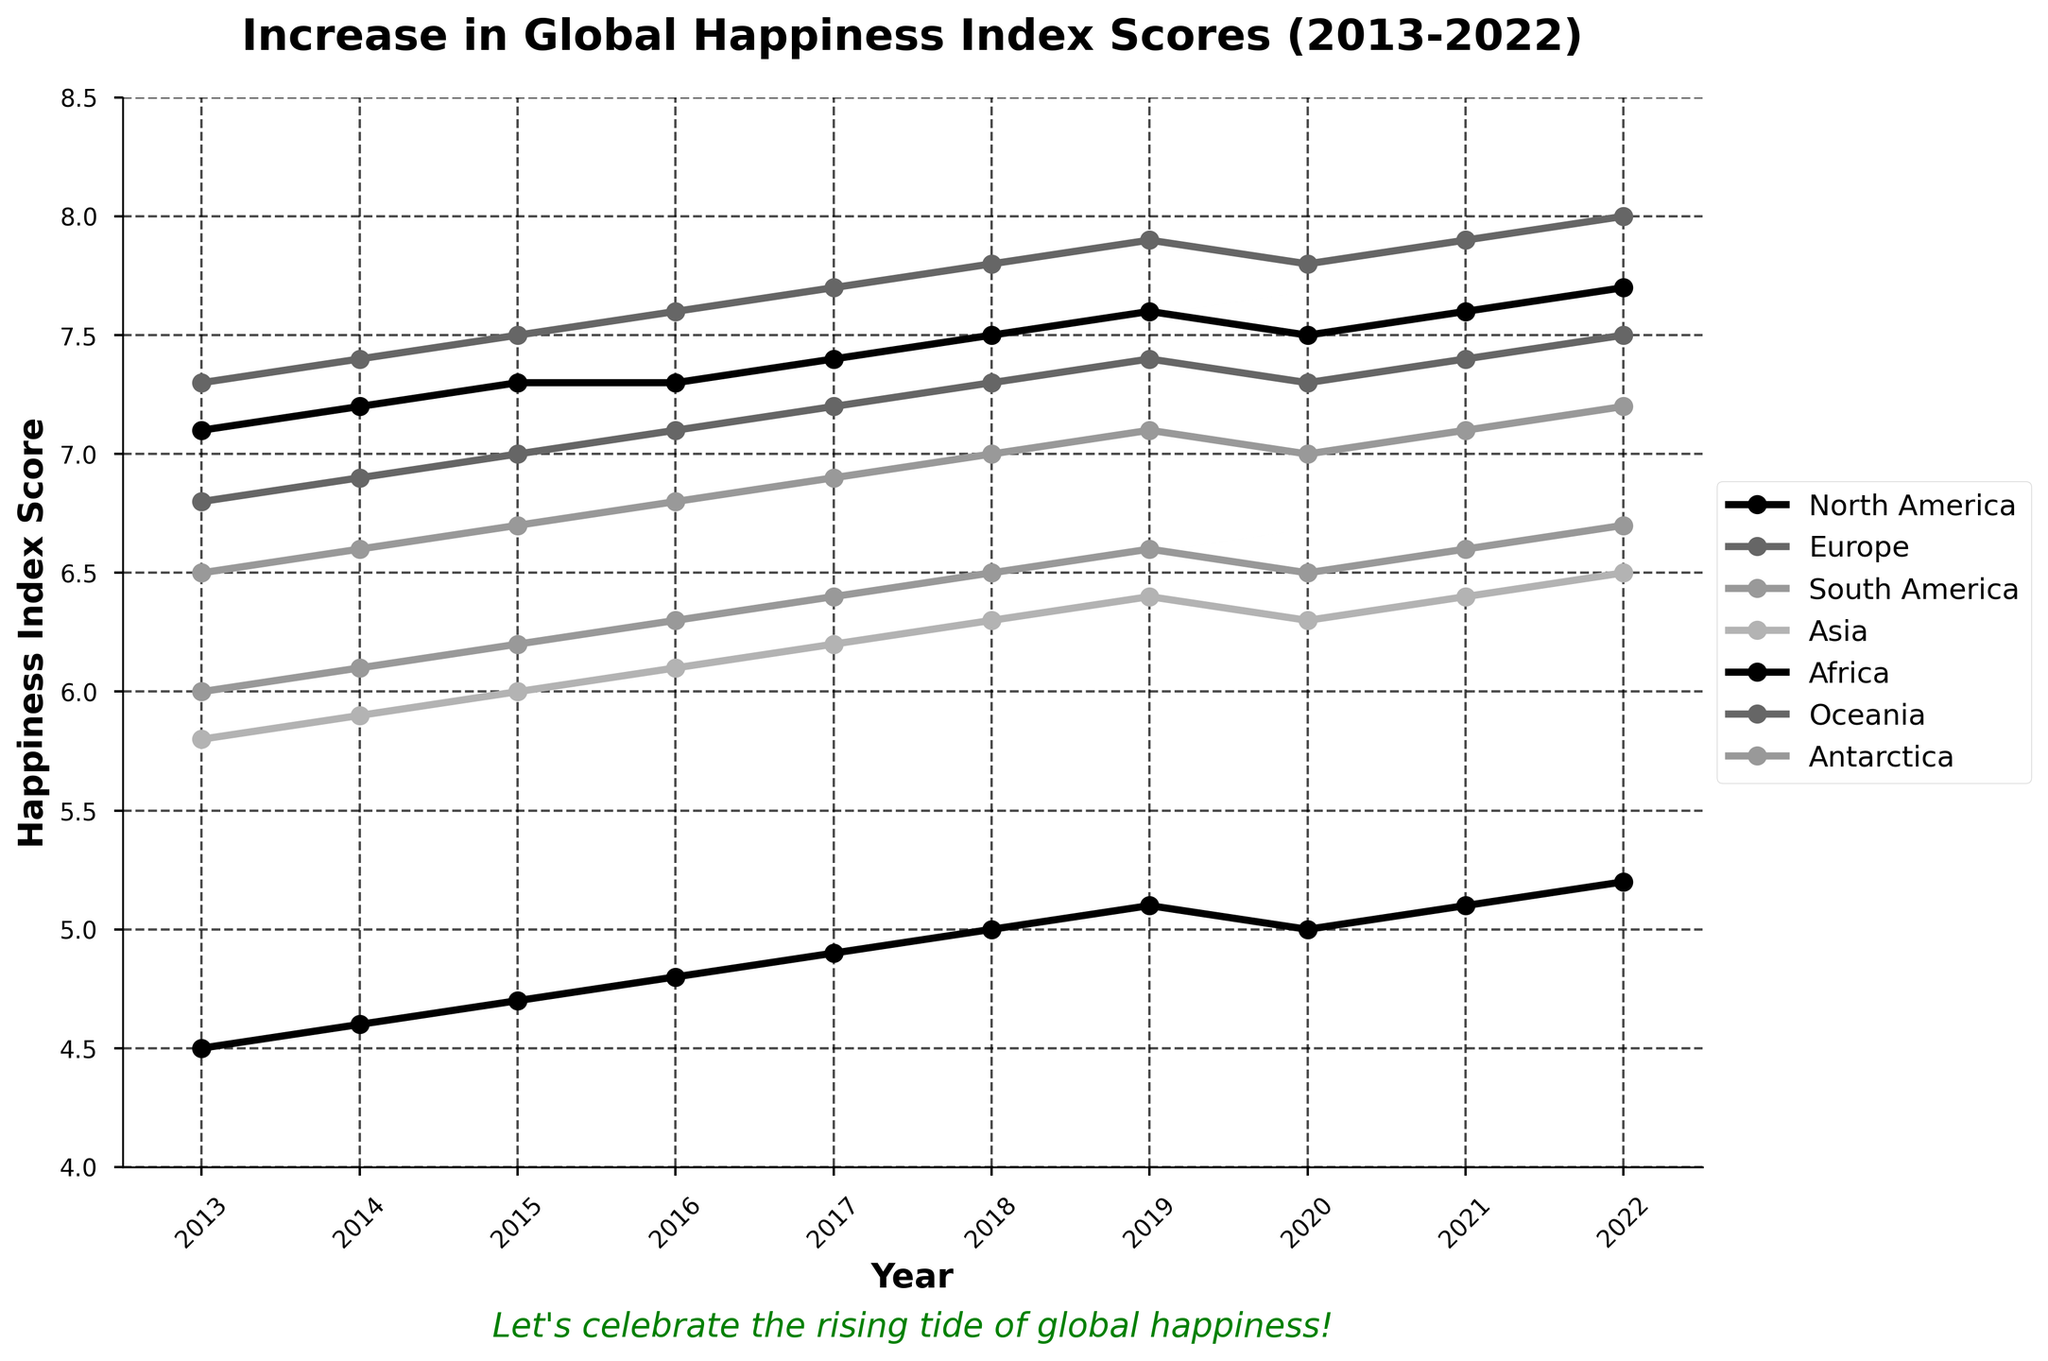What is the trend in happiness index scores for North America from 2013 to 2022? To observe the trend, look at the plotted line for North America. Notice that it starts at 7.1 in 2013 and ends at 7.7 in 2022. The line shows a consistent increase over the years.
Answer: An increasing trend Which continent had the highest happiness index score in 2022? Spot the lines at the 2022 mark on the x-axis and identify the highest point on the y-axis. Oceania's line reaches up to 8.0, which is the highest among all continents in 2022.
Answer: Oceania How much did Africa's happiness index score increase from 2013 to 2022? Calculate the difference between Africa's happiness index scores in 2013 and 2022. In 2013, it was 4.5, and in 2022, it was 5.2. So, 5.2 - 4.5 equals 0.7.
Answer: 0.7 Which two continents had the same happiness index score in 2020? Examine the lines for 2020 and find those that intersect at the same point. Both North America and Europe scored 7.5 in 2020, indicated by their overlapping points.
Answer: North America and Europe What's the difference in happiness index scores between the highest and lowest continents in 2022? Identify the highest and lowest scores in 2022 from the y-axis. Oceania has the highest (8.0), and Africa has the lowest (5.2). The difference is 8.0 - 5.2 = 2.8.
Answer: 2.8 Did any continent experience a decrease in happiness index score in 2020? Observe the plotted lines at the year 2020. Both Asia and Africa show a decrease from 2019 to 2020, as their scores drop from 6.4 to 6.3 for Asia and from 5.1 to 5.0 for Africa.
Answer: Yes Which continent had the most significant overall increase in happiness index score from 2013 to 2022? Calculate the difference between 2013 and 2022 scores for each continent and find the largest one. Oceania increased from 7.3 to 8.0, a difference of 0.7.
Answer: Oceania How did the happiness index score for Asia compare to Europe in 2015? Compare the values for both continents in 2015: Asia is at 6.0 and Europe at 7.0. Europe's score is higher.
Answer: Europe had a higher score What is the average happiness index score across all continents in 2022? Sum up the 2022 scores for all continents and divide by the number of continents. (7.7 + 7.5 + 7.2 + 6.5 + 5.2 + 8.0 + 6.7) / 7 = 6.97.
Answer: 6.97 Which continent showed no drop in happiness index scores at any point over the decade? Analyze each line plot and check if there are any dips. Oceania's line consistently increases or remains steady without any drops.
Answer: Oceania 